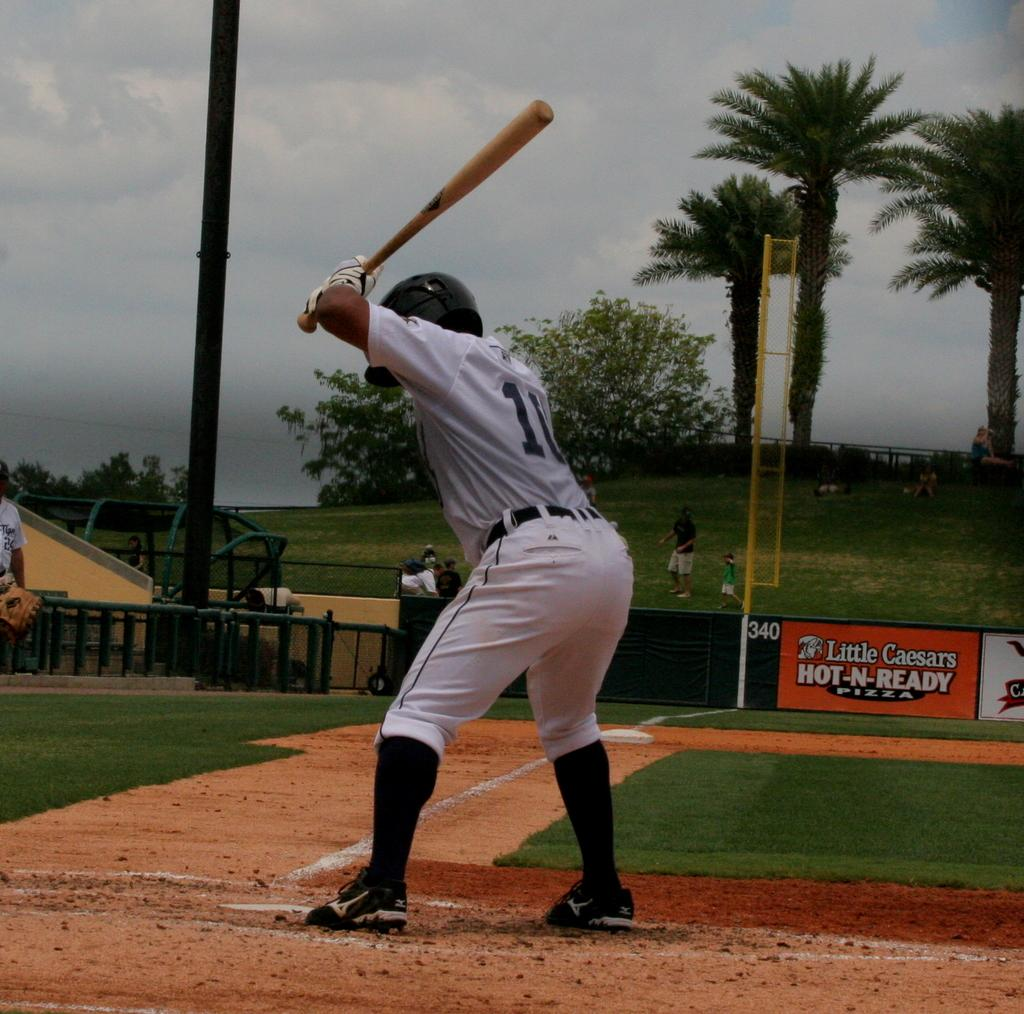<image>
Give a short and clear explanation of the subsequent image. A baseball player is about to swing the bat in front of a Little Caesars sign. 